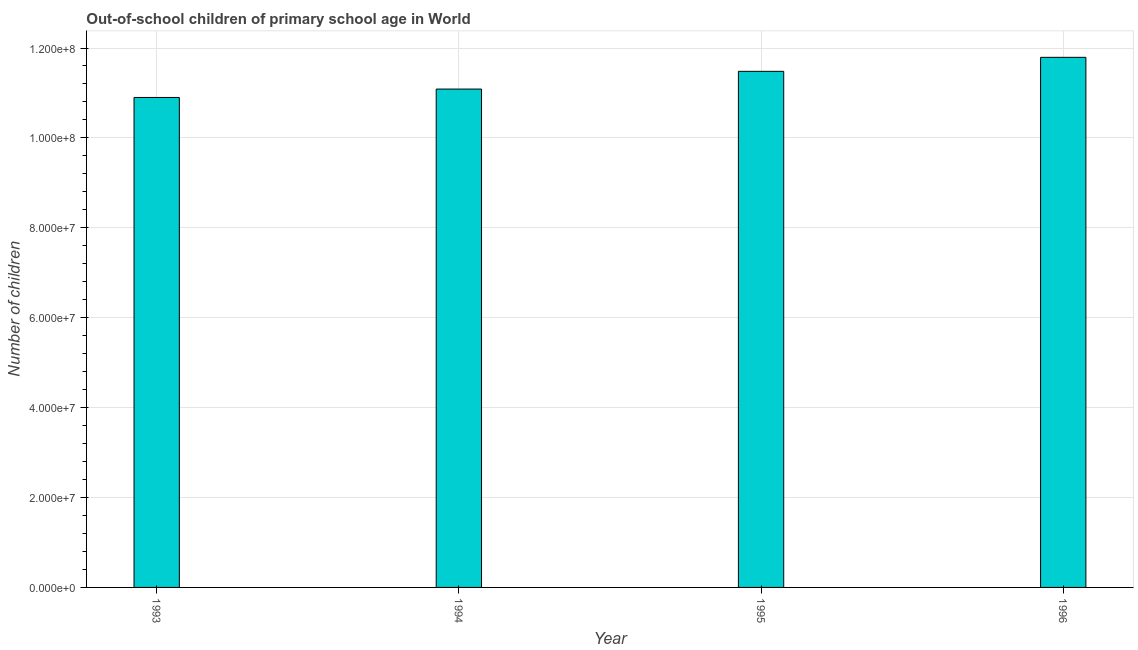Does the graph contain any zero values?
Give a very brief answer. No. What is the title of the graph?
Provide a succinct answer. Out-of-school children of primary school age in World. What is the label or title of the Y-axis?
Provide a succinct answer. Number of children. What is the number of out-of-school children in 1993?
Give a very brief answer. 1.09e+08. Across all years, what is the maximum number of out-of-school children?
Keep it short and to the point. 1.18e+08. Across all years, what is the minimum number of out-of-school children?
Offer a terse response. 1.09e+08. What is the sum of the number of out-of-school children?
Your answer should be very brief. 4.53e+08. What is the difference between the number of out-of-school children in 1994 and 1996?
Ensure brevity in your answer.  -7.06e+06. What is the average number of out-of-school children per year?
Your answer should be very brief. 1.13e+08. What is the median number of out-of-school children?
Your response must be concise. 1.13e+08. In how many years, is the number of out-of-school children greater than 56000000 ?
Provide a short and direct response. 4. What is the ratio of the number of out-of-school children in 1993 to that in 1995?
Your answer should be compact. 0.95. Is the difference between the number of out-of-school children in 1993 and 1995 greater than the difference between any two years?
Keep it short and to the point. No. What is the difference between the highest and the second highest number of out-of-school children?
Your answer should be compact. 3.12e+06. What is the difference between the highest and the lowest number of out-of-school children?
Make the answer very short. 8.93e+06. In how many years, is the number of out-of-school children greater than the average number of out-of-school children taken over all years?
Your answer should be compact. 2. How many bars are there?
Ensure brevity in your answer.  4. Are all the bars in the graph horizontal?
Give a very brief answer. No. Are the values on the major ticks of Y-axis written in scientific E-notation?
Your answer should be very brief. Yes. What is the Number of children of 1993?
Offer a terse response. 1.09e+08. What is the Number of children in 1994?
Provide a succinct answer. 1.11e+08. What is the Number of children of 1995?
Your response must be concise. 1.15e+08. What is the Number of children in 1996?
Ensure brevity in your answer.  1.18e+08. What is the difference between the Number of children in 1993 and 1994?
Offer a terse response. -1.87e+06. What is the difference between the Number of children in 1993 and 1995?
Your answer should be very brief. -5.81e+06. What is the difference between the Number of children in 1993 and 1996?
Offer a very short reply. -8.93e+06. What is the difference between the Number of children in 1994 and 1995?
Offer a very short reply. -3.94e+06. What is the difference between the Number of children in 1994 and 1996?
Your response must be concise. -7.06e+06. What is the difference between the Number of children in 1995 and 1996?
Make the answer very short. -3.12e+06. What is the ratio of the Number of children in 1993 to that in 1995?
Give a very brief answer. 0.95. What is the ratio of the Number of children in 1993 to that in 1996?
Give a very brief answer. 0.92. What is the ratio of the Number of children in 1994 to that in 1996?
Offer a very short reply. 0.94. What is the ratio of the Number of children in 1995 to that in 1996?
Your answer should be very brief. 0.97. 